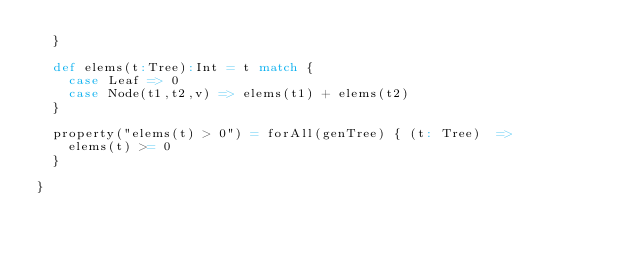Convert code to text. <code><loc_0><loc_0><loc_500><loc_500><_Scala_>  }

  def elems(t:Tree):Int = t match {
    case Leaf => 0
    case Node(t1,t2,v) => elems(t1) + elems(t2)
  }

  property("elems(t) > 0") = forAll(genTree) { (t: Tree)  =>
    elems(t) >= 0
  }

}</code> 